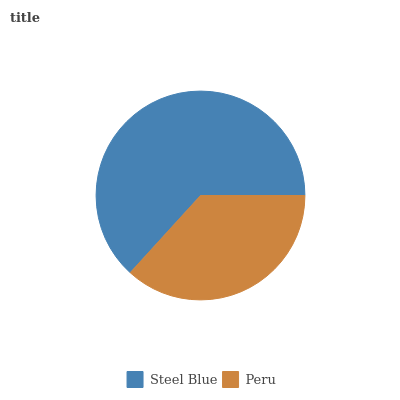Is Peru the minimum?
Answer yes or no. Yes. Is Steel Blue the maximum?
Answer yes or no. Yes. Is Peru the maximum?
Answer yes or no. No. Is Steel Blue greater than Peru?
Answer yes or no. Yes. Is Peru less than Steel Blue?
Answer yes or no. Yes. Is Peru greater than Steel Blue?
Answer yes or no. No. Is Steel Blue less than Peru?
Answer yes or no. No. Is Steel Blue the high median?
Answer yes or no. Yes. Is Peru the low median?
Answer yes or no. Yes. Is Peru the high median?
Answer yes or no. No. Is Steel Blue the low median?
Answer yes or no. No. 